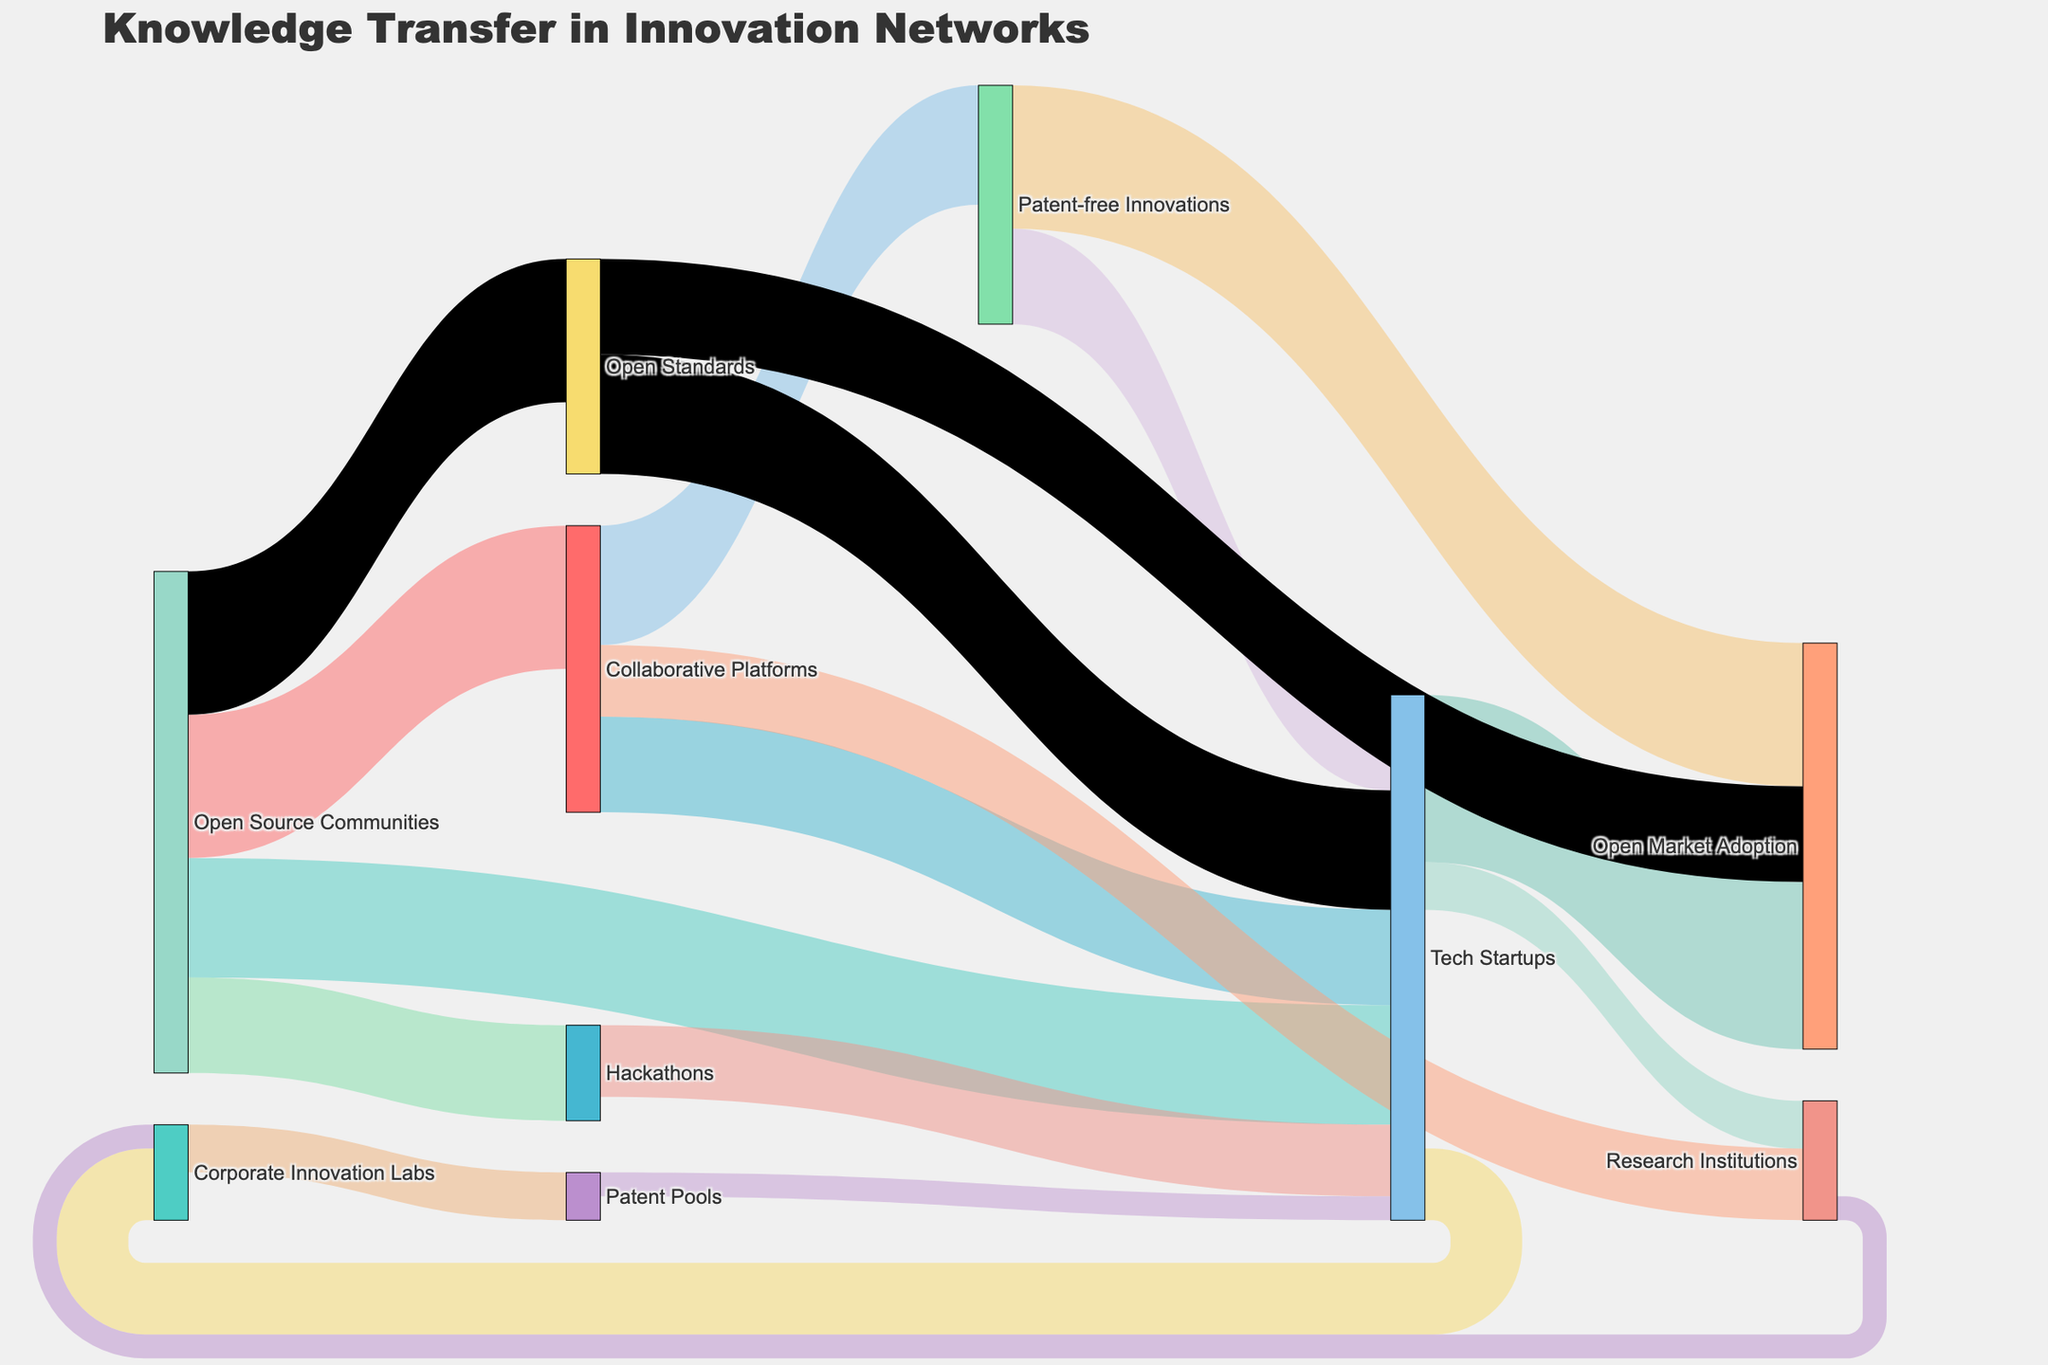what is the main title of the figure? The main title of the figure is located at the top center of the Sankey Diagram and reads "Knowledge Transfer in Innovation Networks".
Answer: Knowledge Transfer in Innovation Networks What are the top three sources of knowledge transfer in the network? By evaluating the Sankey Diagram, the top three sources of knowledge transfer are "Open Source Communities," "Collaborative Platforms," and "Tech Startups" with outbound connections to various targets.
Answer: Open Source Communities, Collaborative Platforms, Tech Startups What is the total amount of knowledge transferred from Open Source Communities? To find this, sum up all the values of arrows originating from Open Source Communities: 30 + 25 + 20 + 30 = 105.
Answer: 105 How much knowledge is transferred from Tech Startups to Open Market Adoption? Move through the diagram and locate the arrow from Tech Startups to Open Market Adoption, which shows a value of 35.
Answer: 35 Which target receives the least knowledge from Research Institutions? Track the arrows coming out from Research Institutions; the recipients are Tech Startups (10) and Corporate Innovation Labs (5). The latter is the smallest.
Answer: Corporate Innovation Labs Compare the knowledge transfer from Hackathons to Tech Startups with the transfer from Open Source Communities to Open Standards. Which one is greater? From the diagram, Hackathons to Tech Startups has a value of 15, while Open Source Communities to Open Standards has a value of 30. Therefore, the latter is greater.
Answer: Open Source Communities to Open Standards Which entity acts as an intermediary for transferring knowledge to Patent-free Innovations? From the diagram, we can see that Collaborative Platforms is the only entity transferring knowledge directly to Patent-free Innovations.
Answer: Collaborative Platforms How many entities have direct outgoing flows to Tech Startups, and what are they? Count the arrows flowing directly to Tech Startups: they come from Open Source Communities, Collaborative Platforms, Hackathons, Patent Pools, and Open Standards, making it 5 entities.
Answer: 5 (Open Source Communities, Collaborative Platforms, Hackathons, Patent Pools, Open Standards) What proportion of knowledge transferred by Open Source Communities goes to Collaborative Platforms? The value to Collaborative Platforms is 30. The total outgoing from Open Source Communities is 105. The proportion is 30/105, which simplifies to approximately 28.57%.
Answer: 28.57% Identify all the end nodes with no outgoing connections. Review the diagram, and end nodes with no outgoing arrows are Open Market Adoption and Patent Pools.
Answer: Open Market Adoption, Patent Pools 